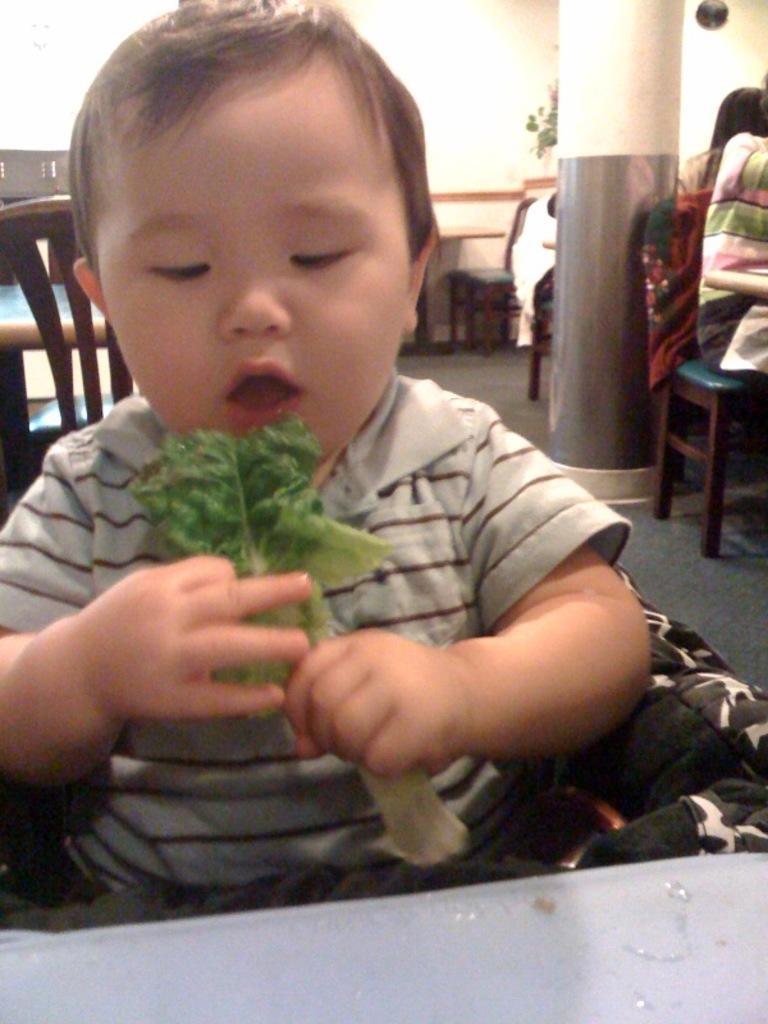Can you describe this image briefly? In the picture there is a little boy with leaves in his hands opened his mouth staring at the leaves. On background there are chairs, table and pillar in the middle. It seems to be in a hotel. 